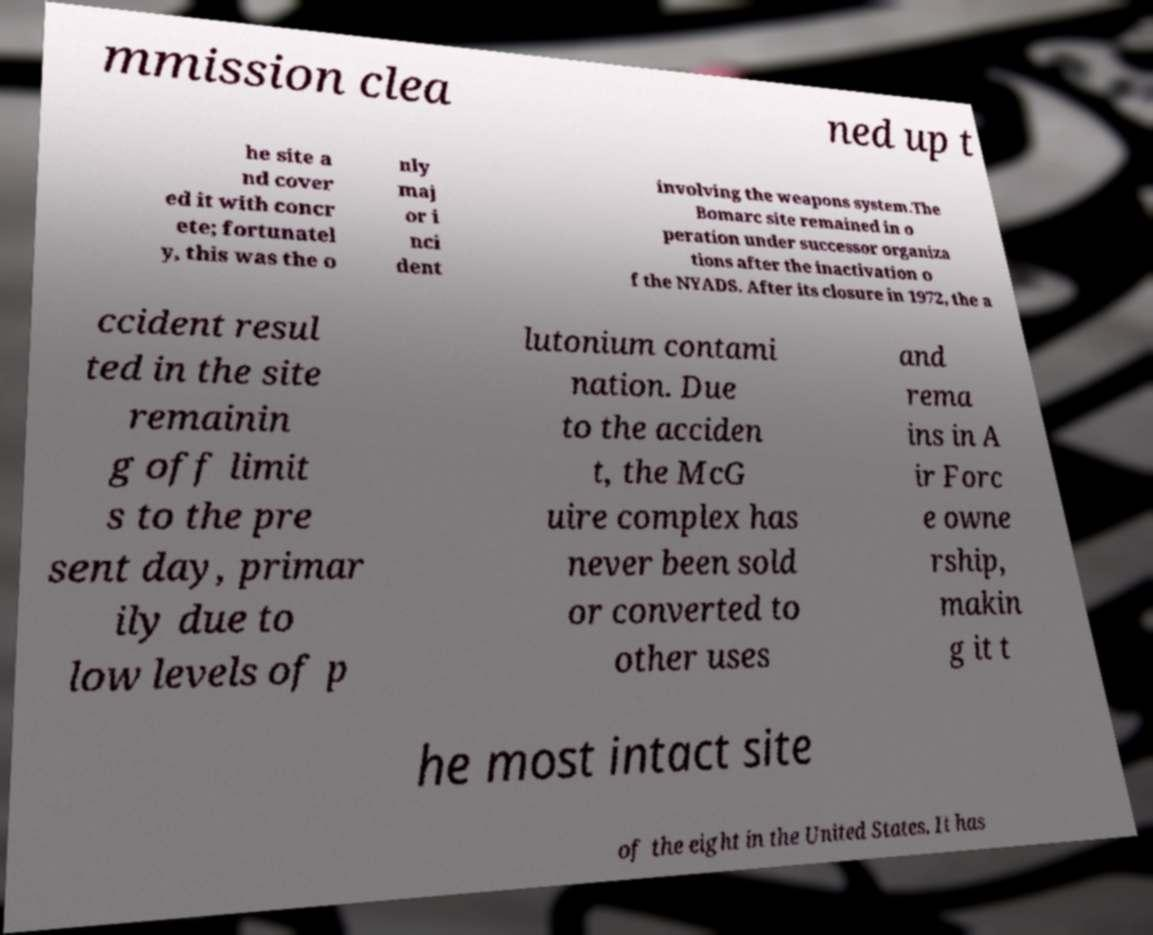For documentation purposes, I need the text within this image transcribed. Could you provide that? mmission clea ned up t he site a nd cover ed it with concr ete; fortunatel y, this was the o nly maj or i nci dent involving the weapons system.The Bomarc site remained in o peration under successor organiza tions after the inactivation o f the NYADS. After its closure in 1972, the a ccident resul ted in the site remainin g off limit s to the pre sent day, primar ily due to low levels of p lutonium contami nation. Due to the acciden t, the McG uire complex has never been sold or converted to other uses and rema ins in A ir Forc e owne rship, makin g it t he most intact site of the eight in the United States. It has 